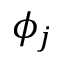<formula> <loc_0><loc_0><loc_500><loc_500>\phi _ { j }</formula> 